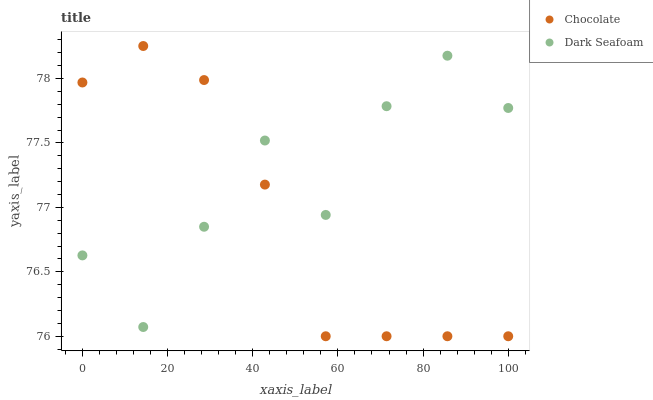Does Chocolate have the minimum area under the curve?
Answer yes or no. Yes. Does Dark Seafoam have the maximum area under the curve?
Answer yes or no. Yes. Does Chocolate have the maximum area under the curve?
Answer yes or no. No. Is Chocolate the smoothest?
Answer yes or no. Yes. Is Dark Seafoam the roughest?
Answer yes or no. Yes. Is Chocolate the roughest?
Answer yes or no. No. Does Chocolate have the lowest value?
Answer yes or no. Yes. Does Chocolate have the highest value?
Answer yes or no. Yes. Does Dark Seafoam intersect Chocolate?
Answer yes or no. Yes. Is Dark Seafoam less than Chocolate?
Answer yes or no. No. Is Dark Seafoam greater than Chocolate?
Answer yes or no. No. 